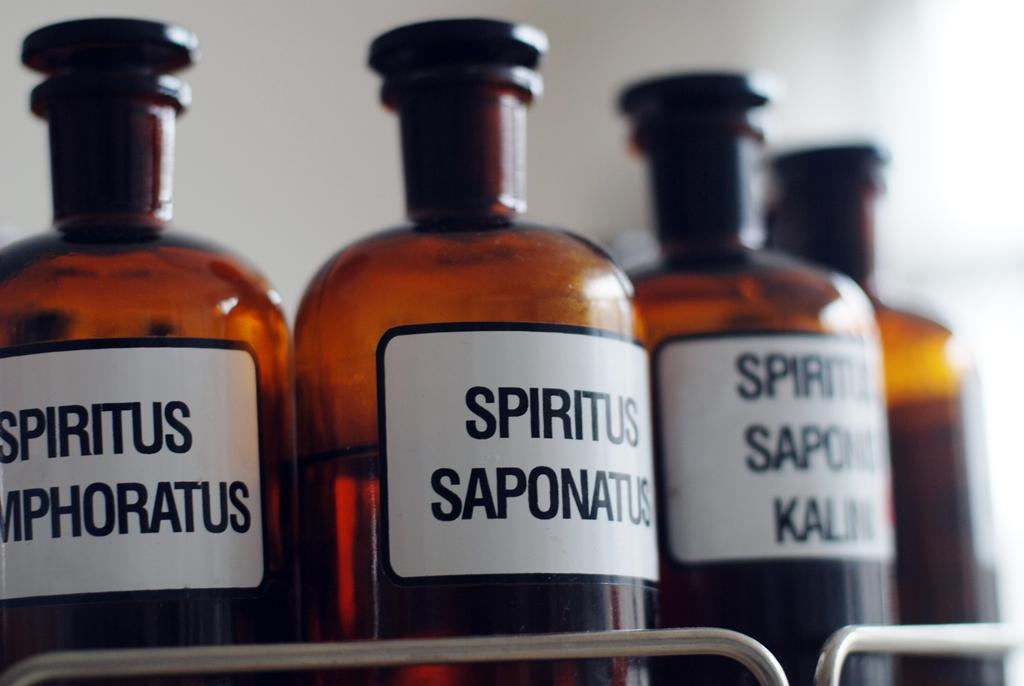<image>
Share a concise interpretation of the image provided. Three different kinds of spirits are displayed here. 